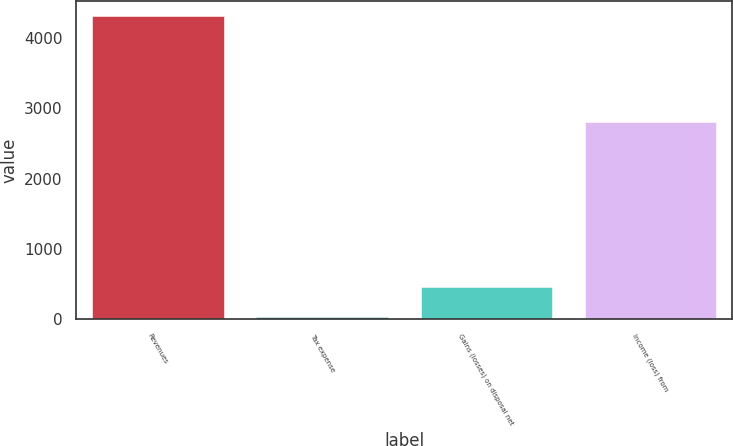Convert chart. <chart><loc_0><loc_0><loc_500><loc_500><bar_chart><fcel>Revenues<fcel>Tax expense<fcel>Gains (losses) on disposal net<fcel>Income (loss) from<nl><fcel>4311<fcel>31<fcel>459<fcel>2809<nl></chart> 